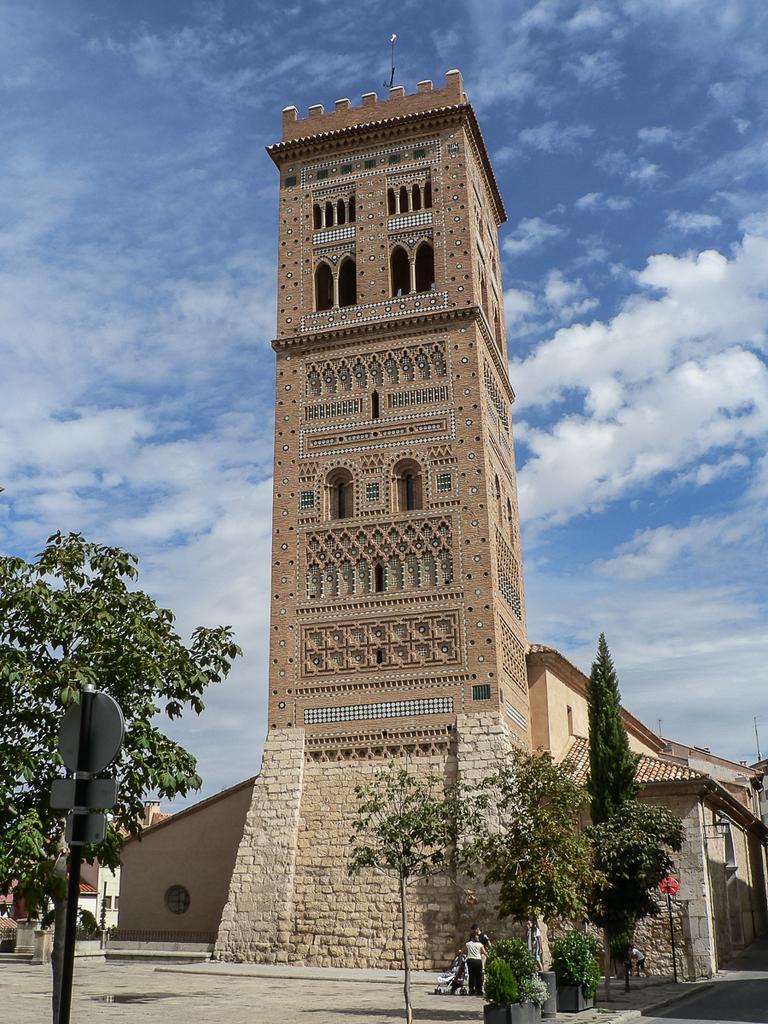How would you summarize this image in a sentence or two? This picture is clicked outside. In the foreground we can see the potted plants, trees, person and boards attached to the metal rod and we can see the sky, buildings, houses and some other objects. 